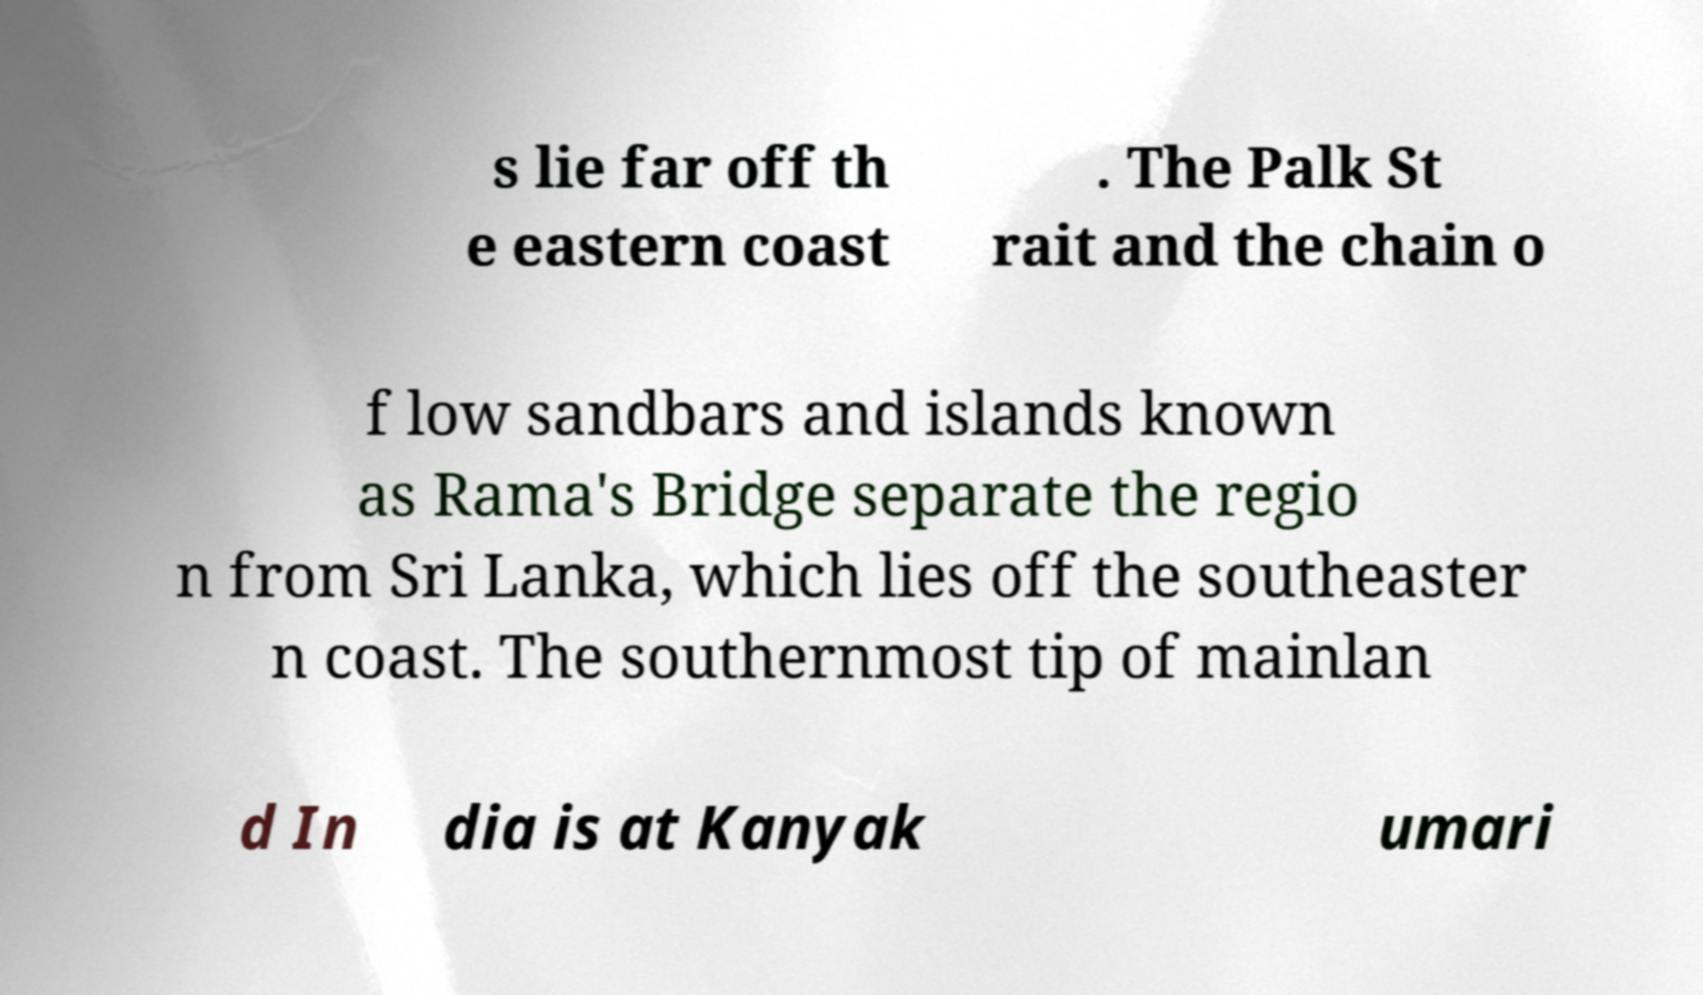Could you assist in decoding the text presented in this image and type it out clearly? s lie far off th e eastern coast . The Palk St rait and the chain o f low sandbars and islands known as Rama's Bridge separate the regio n from Sri Lanka, which lies off the southeaster n coast. The southernmost tip of mainlan d In dia is at Kanyak umari 